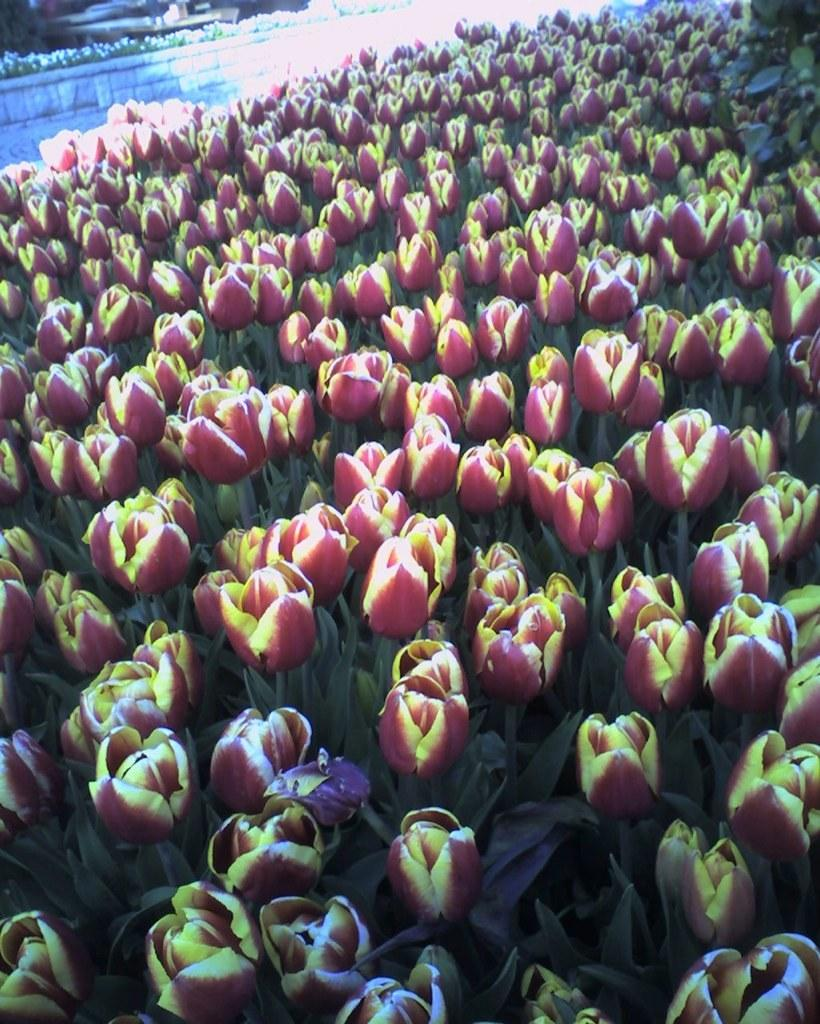What is the main subject in the foreground of the image? There are many flowers in the foreground of the image. What can be seen at the top of the image? There is a tiny wall at the top of the image. Are there any flowers near the wall at the top of the image? Yes, there are flowers near the wall at the top of the image. Can you see a pan filled with water near the flowers in the image? There is no pan filled with water visible in the image. 